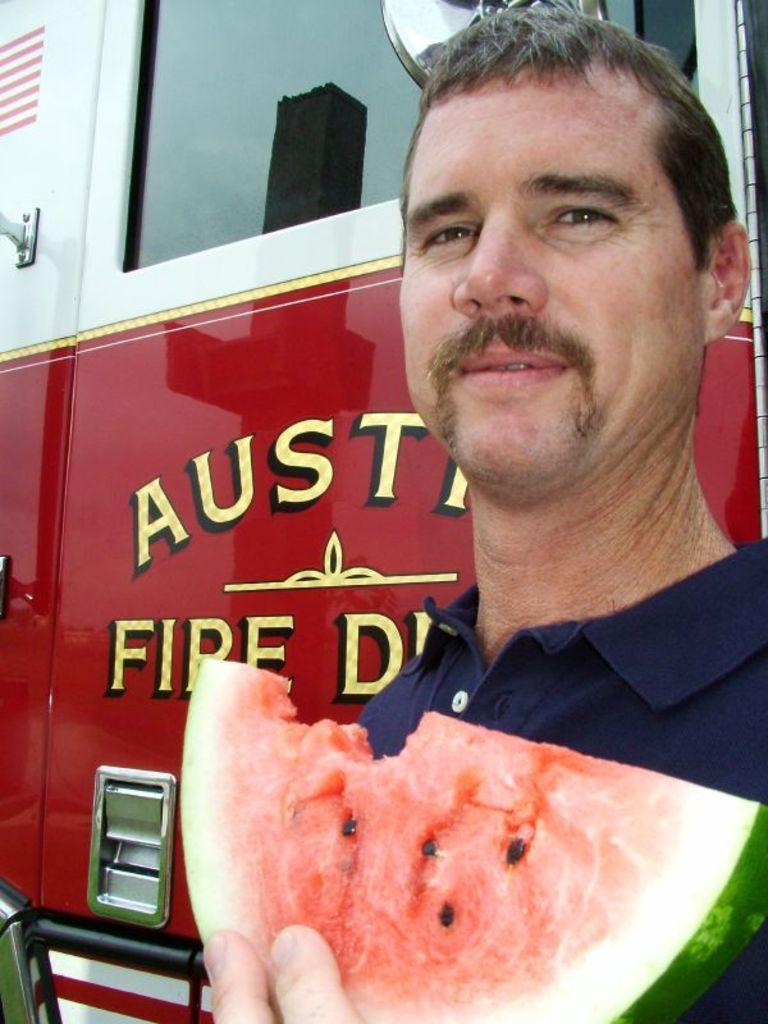What is on the right side of the image? There is a man on the right side of the image. What is the man holding in the image? The man is holding a piece of watermelon. What can be seen behind the man in the image? There is a vehicle visible behind the man. What type of drawer is the man searching through in the image? There is no drawer present in the image; the man is holding a piece of watermelon. 